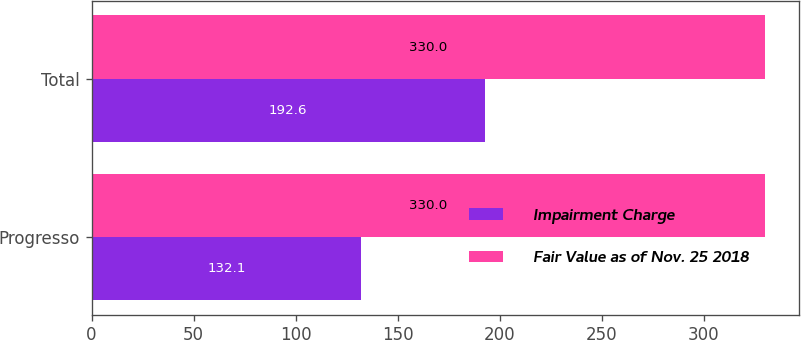Convert chart. <chart><loc_0><loc_0><loc_500><loc_500><stacked_bar_chart><ecel><fcel>Progresso<fcel>Total<nl><fcel>Impairment Charge<fcel>132.1<fcel>192.6<nl><fcel>Fair Value as of Nov. 25 2018<fcel>330<fcel>330<nl></chart> 